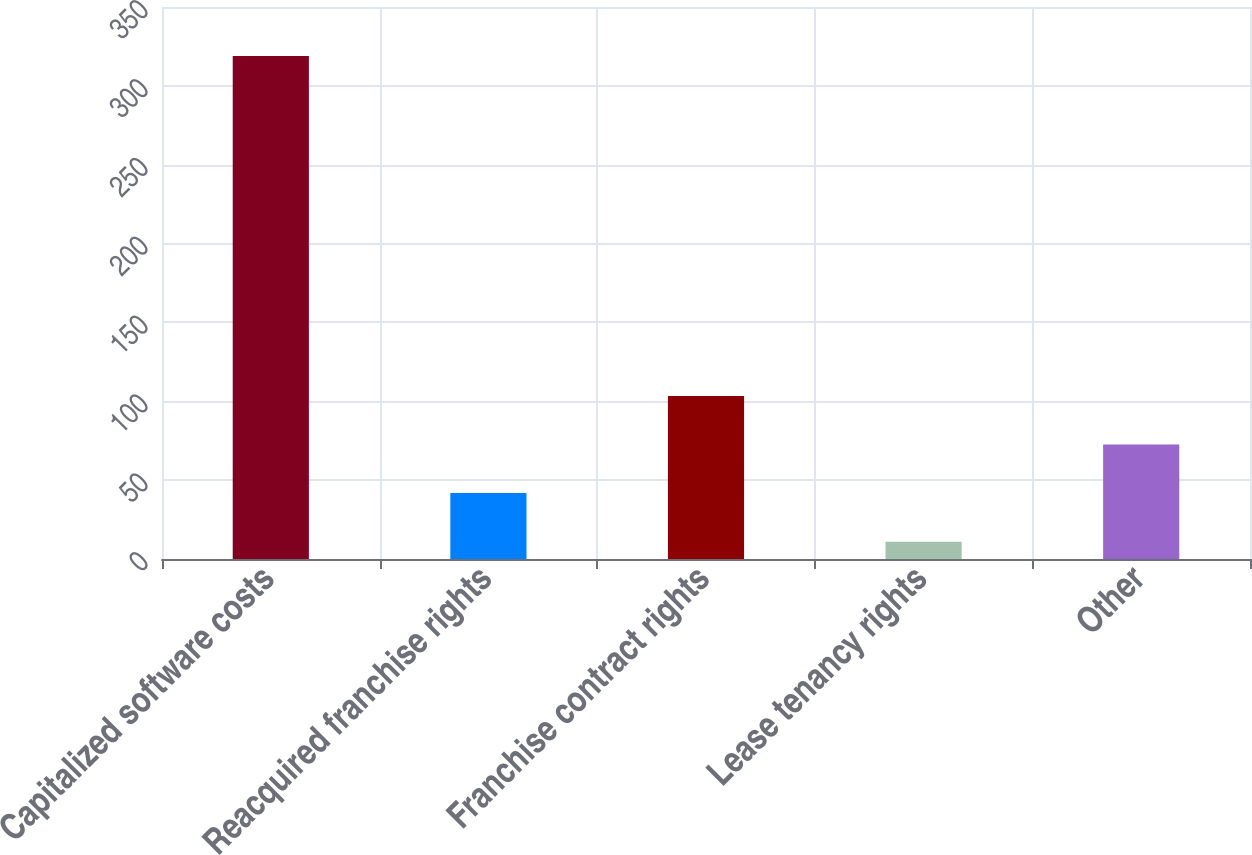<chart> <loc_0><loc_0><loc_500><loc_500><bar_chart><fcel>Capitalized software costs<fcel>Reacquired franchise rights<fcel>Franchise contract rights<fcel>Lease tenancy rights<fcel>Other<nl><fcel>319<fcel>41.8<fcel>103.4<fcel>11<fcel>72.6<nl></chart> 